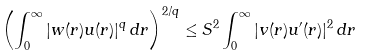Convert formula to latex. <formula><loc_0><loc_0><loc_500><loc_500>\left ( \int _ { 0 } ^ { \infty } | w ( r ) u ( r ) | ^ { q } \, d r \right ) ^ { 2 / q } \leq S ^ { 2 } \int _ { 0 } ^ { \infty } | v ( r ) u ^ { \prime } ( r ) | ^ { 2 } \, d r</formula> 